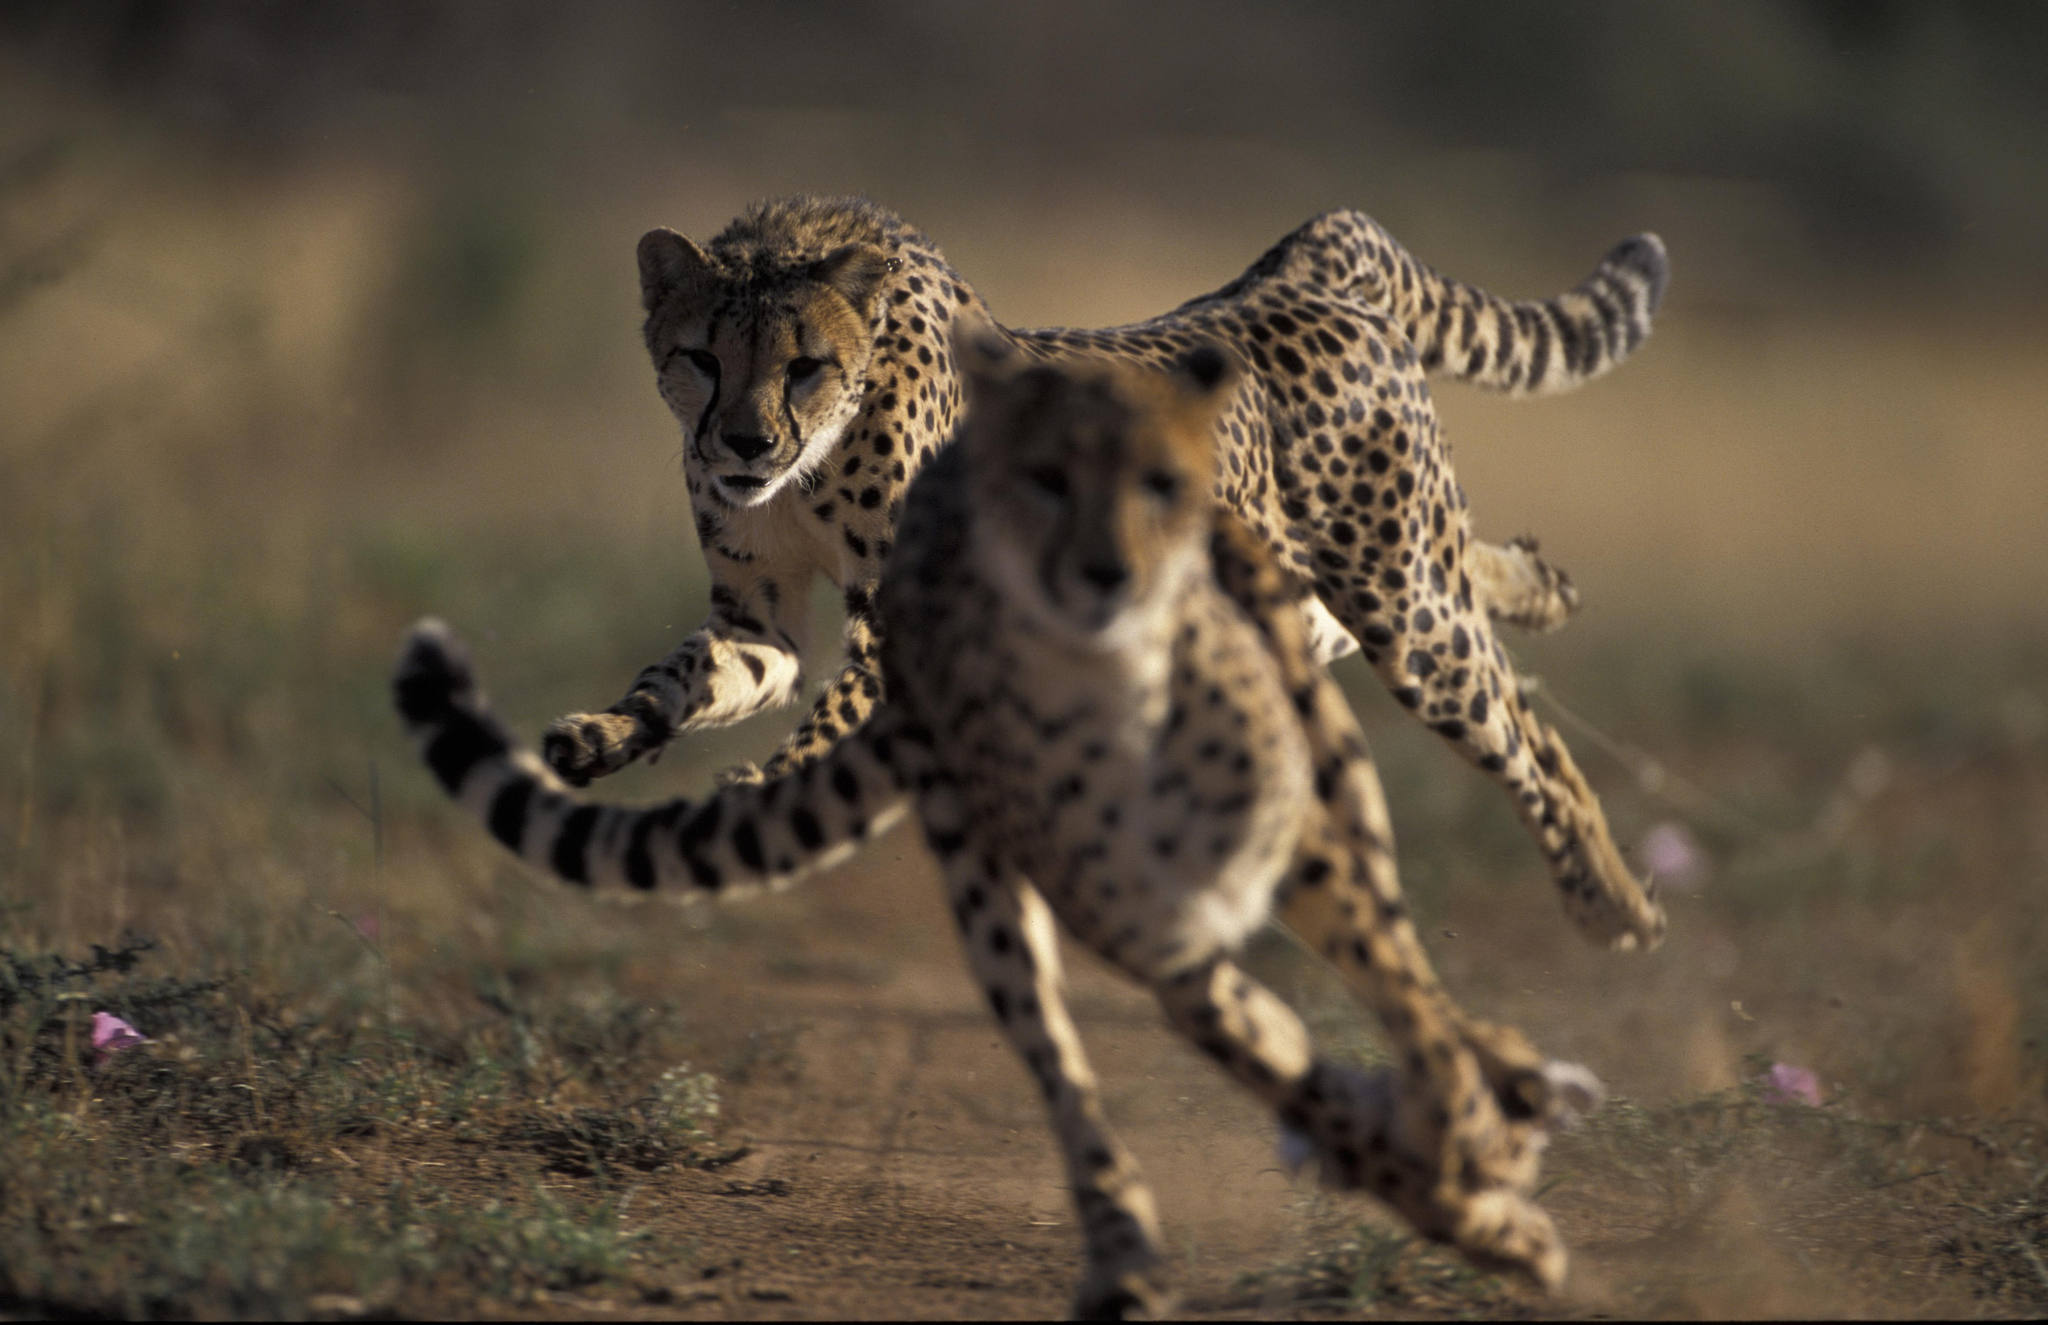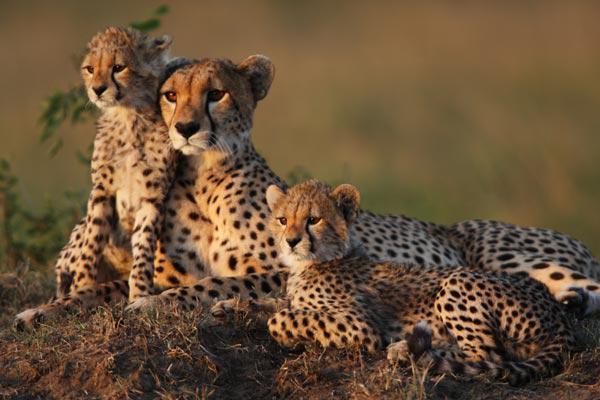The first image is the image on the left, the second image is the image on the right. Assess this claim about the two images: "The right image contains two or less baby cheetahs.". Correct or not? Answer yes or no. Yes. The first image is the image on the left, the second image is the image on the right. For the images shown, is this caption "Left image shows a close group of at least four cheetahs." true? Answer yes or no. No. 